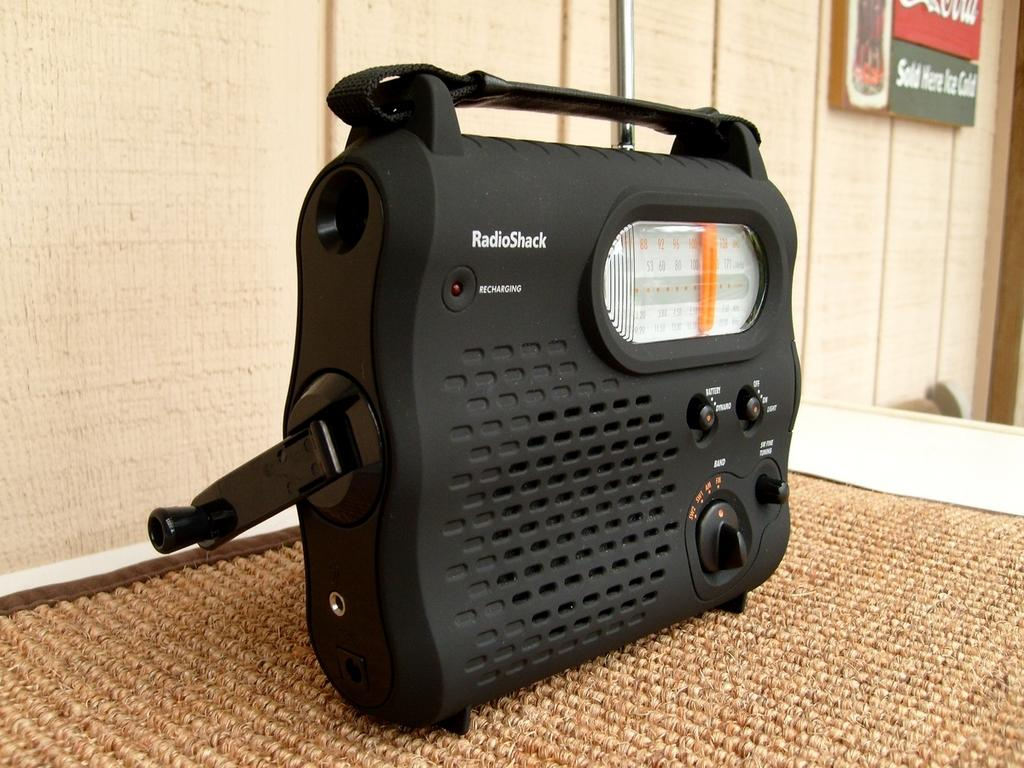What electronic device is visible in the image? There is a radio in the image. Where is the radio placed? The radio is on a mat. What can be seen in the background of the image? There is a wall in the background of the image. What is on the board in the image? There is something written on the board in the image. How many toads are sitting on the radio in the image? There are no toads present in the image; the radio is on a mat. 